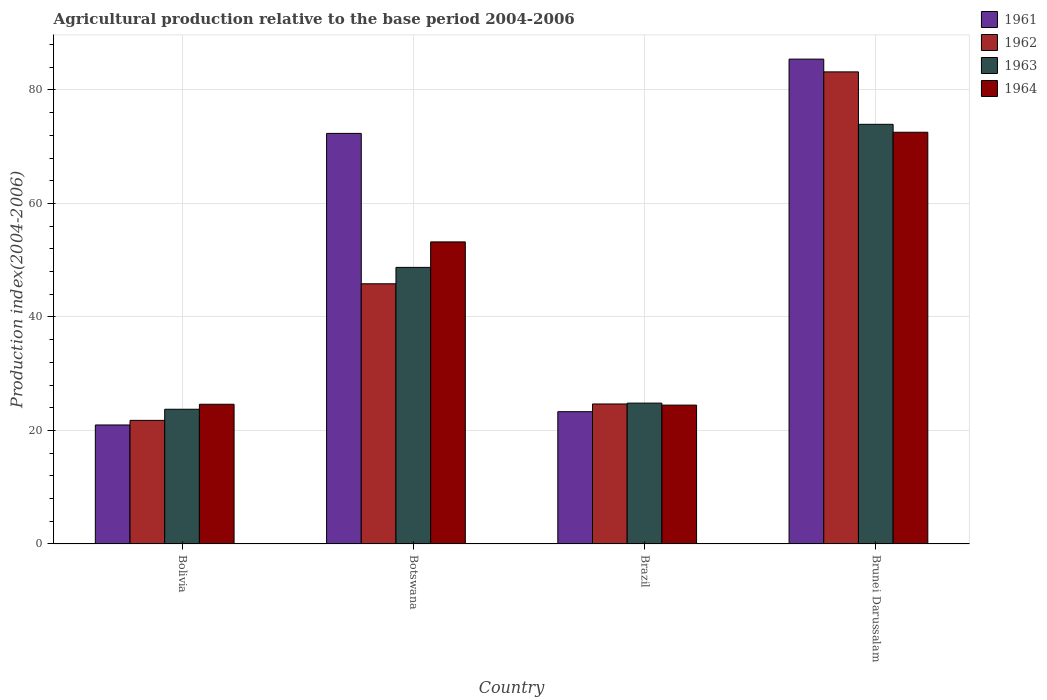How many different coloured bars are there?
Provide a short and direct response. 4. How many groups of bars are there?
Make the answer very short. 4. What is the label of the 4th group of bars from the left?
Your answer should be very brief. Brunei Darussalam. What is the agricultural production index in 1961 in Brunei Darussalam?
Offer a terse response. 85.44. Across all countries, what is the maximum agricultural production index in 1964?
Your answer should be compact. 72.55. Across all countries, what is the minimum agricultural production index in 1962?
Make the answer very short. 21.78. In which country was the agricultural production index in 1962 maximum?
Ensure brevity in your answer.  Brunei Darussalam. What is the total agricultural production index in 1963 in the graph?
Your response must be concise. 171.25. What is the difference between the agricultural production index in 1962 in Bolivia and that in Brazil?
Make the answer very short. -2.89. What is the difference between the agricultural production index in 1964 in Bolivia and the agricultural production index in 1963 in Botswana?
Your response must be concise. -24.12. What is the average agricultural production index in 1964 per country?
Ensure brevity in your answer.  43.72. What is the difference between the agricultural production index of/in 1963 and agricultural production index of/in 1962 in Brazil?
Your answer should be very brief. 0.15. In how many countries, is the agricultural production index in 1963 greater than 52?
Keep it short and to the point. 1. What is the ratio of the agricultural production index in 1962 in Bolivia to that in Botswana?
Ensure brevity in your answer.  0.48. Is the difference between the agricultural production index in 1963 in Botswana and Brunei Darussalam greater than the difference between the agricultural production index in 1962 in Botswana and Brunei Darussalam?
Provide a short and direct response. Yes. What is the difference between the highest and the second highest agricultural production index in 1964?
Offer a terse response. 47.93. What is the difference between the highest and the lowest agricultural production index in 1964?
Your answer should be compact. 48.08. Is the sum of the agricultural production index in 1963 in Bolivia and Brunei Darussalam greater than the maximum agricultural production index in 1964 across all countries?
Your response must be concise. Yes. What does the 4th bar from the left in Botswana represents?
Your answer should be compact. 1964. What does the 1st bar from the right in Brunei Darussalam represents?
Keep it short and to the point. 1964. How many countries are there in the graph?
Provide a short and direct response. 4. Does the graph contain any zero values?
Ensure brevity in your answer.  No. Does the graph contain grids?
Make the answer very short. Yes. How are the legend labels stacked?
Your response must be concise. Vertical. What is the title of the graph?
Offer a very short reply. Agricultural production relative to the base period 2004-2006. Does "1999" appear as one of the legend labels in the graph?
Provide a short and direct response. No. What is the label or title of the Y-axis?
Provide a short and direct response. Production index(2004-2006). What is the Production index(2004-2006) in 1961 in Bolivia?
Give a very brief answer. 20.97. What is the Production index(2004-2006) in 1962 in Bolivia?
Keep it short and to the point. 21.78. What is the Production index(2004-2006) of 1963 in Bolivia?
Offer a very short reply. 23.74. What is the Production index(2004-2006) in 1964 in Bolivia?
Your response must be concise. 24.62. What is the Production index(2004-2006) of 1961 in Botswana?
Offer a terse response. 72.35. What is the Production index(2004-2006) in 1962 in Botswana?
Make the answer very short. 45.85. What is the Production index(2004-2006) of 1963 in Botswana?
Your response must be concise. 48.74. What is the Production index(2004-2006) in 1964 in Botswana?
Provide a succinct answer. 53.23. What is the Production index(2004-2006) in 1961 in Brazil?
Ensure brevity in your answer.  23.31. What is the Production index(2004-2006) in 1962 in Brazil?
Make the answer very short. 24.67. What is the Production index(2004-2006) in 1963 in Brazil?
Your response must be concise. 24.82. What is the Production index(2004-2006) in 1964 in Brazil?
Your answer should be compact. 24.47. What is the Production index(2004-2006) in 1961 in Brunei Darussalam?
Make the answer very short. 85.44. What is the Production index(2004-2006) of 1962 in Brunei Darussalam?
Keep it short and to the point. 83.19. What is the Production index(2004-2006) in 1963 in Brunei Darussalam?
Give a very brief answer. 73.95. What is the Production index(2004-2006) in 1964 in Brunei Darussalam?
Your response must be concise. 72.55. Across all countries, what is the maximum Production index(2004-2006) of 1961?
Ensure brevity in your answer.  85.44. Across all countries, what is the maximum Production index(2004-2006) of 1962?
Your response must be concise. 83.19. Across all countries, what is the maximum Production index(2004-2006) in 1963?
Provide a succinct answer. 73.95. Across all countries, what is the maximum Production index(2004-2006) of 1964?
Keep it short and to the point. 72.55. Across all countries, what is the minimum Production index(2004-2006) of 1961?
Your answer should be very brief. 20.97. Across all countries, what is the minimum Production index(2004-2006) in 1962?
Make the answer very short. 21.78. Across all countries, what is the minimum Production index(2004-2006) in 1963?
Ensure brevity in your answer.  23.74. Across all countries, what is the minimum Production index(2004-2006) in 1964?
Your answer should be compact. 24.47. What is the total Production index(2004-2006) of 1961 in the graph?
Ensure brevity in your answer.  202.07. What is the total Production index(2004-2006) of 1962 in the graph?
Make the answer very short. 175.49. What is the total Production index(2004-2006) of 1963 in the graph?
Ensure brevity in your answer.  171.25. What is the total Production index(2004-2006) in 1964 in the graph?
Your response must be concise. 174.87. What is the difference between the Production index(2004-2006) of 1961 in Bolivia and that in Botswana?
Your response must be concise. -51.38. What is the difference between the Production index(2004-2006) of 1962 in Bolivia and that in Botswana?
Offer a very short reply. -24.07. What is the difference between the Production index(2004-2006) in 1963 in Bolivia and that in Botswana?
Provide a succinct answer. -25. What is the difference between the Production index(2004-2006) of 1964 in Bolivia and that in Botswana?
Ensure brevity in your answer.  -28.61. What is the difference between the Production index(2004-2006) in 1961 in Bolivia and that in Brazil?
Your answer should be compact. -2.34. What is the difference between the Production index(2004-2006) of 1962 in Bolivia and that in Brazil?
Make the answer very short. -2.89. What is the difference between the Production index(2004-2006) in 1963 in Bolivia and that in Brazil?
Keep it short and to the point. -1.08. What is the difference between the Production index(2004-2006) of 1964 in Bolivia and that in Brazil?
Make the answer very short. 0.15. What is the difference between the Production index(2004-2006) of 1961 in Bolivia and that in Brunei Darussalam?
Keep it short and to the point. -64.47. What is the difference between the Production index(2004-2006) of 1962 in Bolivia and that in Brunei Darussalam?
Keep it short and to the point. -61.41. What is the difference between the Production index(2004-2006) in 1963 in Bolivia and that in Brunei Darussalam?
Make the answer very short. -50.21. What is the difference between the Production index(2004-2006) in 1964 in Bolivia and that in Brunei Darussalam?
Make the answer very short. -47.93. What is the difference between the Production index(2004-2006) of 1961 in Botswana and that in Brazil?
Provide a succinct answer. 49.04. What is the difference between the Production index(2004-2006) in 1962 in Botswana and that in Brazil?
Make the answer very short. 21.18. What is the difference between the Production index(2004-2006) in 1963 in Botswana and that in Brazil?
Offer a very short reply. 23.92. What is the difference between the Production index(2004-2006) of 1964 in Botswana and that in Brazil?
Your answer should be compact. 28.76. What is the difference between the Production index(2004-2006) of 1961 in Botswana and that in Brunei Darussalam?
Offer a terse response. -13.09. What is the difference between the Production index(2004-2006) in 1962 in Botswana and that in Brunei Darussalam?
Your answer should be very brief. -37.34. What is the difference between the Production index(2004-2006) in 1963 in Botswana and that in Brunei Darussalam?
Your answer should be very brief. -25.21. What is the difference between the Production index(2004-2006) in 1964 in Botswana and that in Brunei Darussalam?
Provide a short and direct response. -19.32. What is the difference between the Production index(2004-2006) of 1961 in Brazil and that in Brunei Darussalam?
Give a very brief answer. -62.13. What is the difference between the Production index(2004-2006) of 1962 in Brazil and that in Brunei Darussalam?
Offer a terse response. -58.52. What is the difference between the Production index(2004-2006) of 1963 in Brazil and that in Brunei Darussalam?
Keep it short and to the point. -49.13. What is the difference between the Production index(2004-2006) in 1964 in Brazil and that in Brunei Darussalam?
Your response must be concise. -48.08. What is the difference between the Production index(2004-2006) of 1961 in Bolivia and the Production index(2004-2006) of 1962 in Botswana?
Your answer should be compact. -24.88. What is the difference between the Production index(2004-2006) of 1961 in Bolivia and the Production index(2004-2006) of 1963 in Botswana?
Give a very brief answer. -27.77. What is the difference between the Production index(2004-2006) in 1961 in Bolivia and the Production index(2004-2006) in 1964 in Botswana?
Your answer should be compact. -32.26. What is the difference between the Production index(2004-2006) of 1962 in Bolivia and the Production index(2004-2006) of 1963 in Botswana?
Provide a short and direct response. -26.96. What is the difference between the Production index(2004-2006) of 1962 in Bolivia and the Production index(2004-2006) of 1964 in Botswana?
Give a very brief answer. -31.45. What is the difference between the Production index(2004-2006) of 1963 in Bolivia and the Production index(2004-2006) of 1964 in Botswana?
Provide a short and direct response. -29.49. What is the difference between the Production index(2004-2006) of 1961 in Bolivia and the Production index(2004-2006) of 1962 in Brazil?
Offer a very short reply. -3.7. What is the difference between the Production index(2004-2006) in 1961 in Bolivia and the Production index(2004-2006) in 1963 in Brazil?
Provide a succinct answer. -3.85. What is the difference between the Production index(2004-2006) of 1961 in Bolivia and the Production index(2004-2006) of 1964 in Brazil?
Your answer should be compact. -3.5. What is the difference between the Production index(2004-2006) in 1962 in Bolivia and the Production index(2004-2006) in 1963 in Brazil?
Keep it short and to the point. -3.04. What is the difference between the Production index(2004-2006) of 1962 in Bolivia and the Production index(2004-2006) of 1964 in Brazil?
Provide a short and direct response. -2.69. What is the difference between the Production index(2004-2006) of 1963 in Bolivia and the Production index(2004-2006) of 1964 in Brazil?
Offer a terse response. -0.73. What is the difference between the Production index(2004-2006) of 1961 in Bolivia and the Production index(2004-2006) of 1962 in Brunei Darussalam?
Offer a terse response. -62.22. What is the difference between the Production index(2004-2006) of 1961 in Bolivia and the Production index(2004-2006) of 1963 in Brunei Darussalam?
Offer a terse response. -52.98. What is the difference between the Production index(2004-2006) in 1961 in Bolivia and the Production index(2004-2006) in 1964 in Brunei Darussalam?
Your response must be concise. -51.58. What is the difference between the Production index(2004-2006) of 1962 in Bolivia and the Production index(2004-2006) of 1963 in Brunei Darussalam?
Your response must be concise. -52.17. What is the difference between the Production index(2004-2006) of 1962 in Bolivia and the Production index(2004-2006) of 1964 in Brunei Darussalam?
Provide a succinct answer. -50.77. What is the difference between the Production index(2004-2006) of 1963 in Bolivia and the Production index(2004-2006) of 1964 in Brunei Darussalam?
Give a very brief answer. -48.81. What is the difference between the Production index(2004-2006) in 1961 in Botswana and the Production index(2004-2006) in 1962 in Brazil?
Offer a terse response. 47.68. What is the difference between the Production index(2004-2006) in 1961 in Botswana and the Production index(2004-2006) in 1963 in Brazil?
Offer a very short reply. 47.53. What is the difference between the Production index(2004-2006) of 1961 in Botswana and the Production index(2004-2006) of 1964 in Brazil?
Your response must be concise. 47.88. What is the difference between the Production index(2004-2006) in 1962 in Botswana and the Production index(2004-2006) in 1963 in Brazil?
Offer a terse response. 21.03. What is the difference between the Production index(2004-2006) of 1962 in Botswana and the Production index(2004-2006) of 1964 in Brazil?
Make the answer very short. 21.38. What is the difference between the Production index(2004-2006) of 1963 in Botswana and the Production index(2004-2006) of 1964 in Brazil?
Your answer should be very brief. 24.27. What is the difference between the Production index(2004-2006) in 1961 in Botswana and the Production index(2004-2006) in 1962 in Brunei Darussalam?
Keep it short and to the point. -10.84. What is the difference between the Production index(2004-2006) of 1961 in Botswana and the Production index(2004-2006) of 1963 in Brunei Darussalam?
Keep it short and to the point. -1.6. What is the difference between the Production index(2004-2006) in 1961 in Botswana and the Production index(2004-2006) in 1964 in Brunei Darussalam?
Your response must be concise. -0.2. What is the difference between the Production index(2004-2006) of 1962 in Botswana and the Production index(2004-2006) of 1963 in Brunei Darussalam?
Offer a very short reply. -28.1. What is the difference between the Production index(2004-2006) of 1962 in Botswana and the Production index(2004-2006) of 1964 in Brunei Darussalam?
Your answer should be very brief. -26.7. What is the difference between the Production index(2004-2006) of 1963 in Botswana and the Production index(2004-2006) of 1964 in Brunei Darussalam?
Give a very brief answer. -23.81. What is the difference between the Production index(2004-2006) of 1961 in Brazil and the Production index(2004-2006) of 1962 in Brunei Darussalam?
Your answer should be very brief. -59.88. What is the difference between the Production index(2004-2006) of 1961 in Brazil and the Production index(2004-2006) of 1963 in Brunei Darussalam?
Offer a very short reply. -50.64. What is the difference between the Production index(2004-2006) of 1961 in Brazil and the Production index(2004-2006) of 1964 in Brunei Darussalam?
Give a very brief answer. -49.24. What is the difference between the Production index(2004-2006) in 1962 in Brazil and the Production index(2004-2006) in 1963 in Brunei Darussalam?
Your response must be concise. -49.28. What is the difference between the Production index(2004-2006) of 1962 in Brazil and the Production index(2004-2006) of 1964 in Brunei Darussalam?
Your answer should be very brief. -47.88. What is the difference between the Production index(2004-2006) in 1963 in Brazil and the Production index(2004-2006) in 1964 in Brunei Darussalam?
Your answer should be compact. -47.73. What is the average Production index(2004-2006) of 1961 per country?
Your answer should be compact. 50.52. What is the average Production index(2004-2006) in 1962 per country?
Provide a short and direct response. 43.87. What is the average Production index(2004-2006) in 1963 per country?
Offer a terse response. 42.81. What is the average Production index(2004-2006) in 1964 per country?
Make the answer very short. 43.72. What is the difference between the Production index(2004-2006) of 1961 and Production index(2004-2006) of 1962 in Bolivia?
Your answer should be very brief. -0.81. What is the difference between the Production index(2004-2006) in 1961 and Production index(2004-2006) in 1963 in Bolivia?
Provide a succinct answer. -2.77. What is the difference between the Production index(2004-2006) in 1961 and Production index(2004-2006) in 1964 in Bolivia?
Make the answer very short. -3.65. What is the difference between the Production index(2004-2006) of 1962 and Production index(2004-2006) of 1963 in Bolivia?
Your answer should be very brief. -1.96. What is the difference between the Production index(2004-2006) in 1962 and Production index(2004-2006) in 1964 in Bolivia?
Provide a short and direct response. -2.84. What is the difference between the Production index(2004-2006) of 1963 and Production index(2004-2006) of 1964 in Bolivia?
Your answer should be compact. -0.88. What is the difference between the Production index(2004-2006) in 1961 and Production index(2004-2006) in 1963 in Botswana?
Give a very brief answer. 23.61. What is the difference between the Production index(2004-2006) of 1961 and Production index(2004-2006) of 1964 in Botswana?
Your response must be concise. 19.12. What is the difference between the Production index(2004-2006) of 1962 and Production index(2004-2006) of 1963 in Botswana?
Keep it short and to the point. -2.89. What is the difference between the Production index(2004-2006) of 1962 and Production index(2004-2006) of 1964 in Botswana?
Offer a terse response. -7.38. What is the difference between the Production index(2004-2006) of 1963 and Production index(2004-2006) of 1964 in Botswana?
Give a very brief answer. -4.49. What is the difference between the Production index(2004-2006) in 1961 and Production index(2004-2006) in 1962 in Brazil?
Offer a very short reply. -1.36. What is the difference between the Production index(2004-2006) of 1961 and Production index(2004-2006) of 1963 in Brazil?
Your answer should be very brief. -1.51. What is the difference between the Production index(2004-2006) of 1961 and Production index(2004-2006) of 1964 in Brazil?
Your response must be concise. -1.16. What is the difference between the Production index(2004-2006) in 1961 and Production index(2004-2006) in 1962 in Brunei Darussalam?
Your answer should be very brief. 2.25. What is the difference between the Production index(2004-2006) of 1961 and Production index(2004-2006) of 1963 in Brunei Darussalam?
Offer a terse response. 11.49. What is the difference between the Production index(2004-2006) in 1961 and Production index(2004-2006) in 1964 in Brunei Darussalam?
Provide a succinct answer. 12.89. What is the difference between the Production index(2004-2006) in 1962 and Production index(2004-2006) in 1963 in Brunei Darussalam?
Provide a succinct answer. 9.24. What is the difference between the Production index(2004-2006) of 1962 and Production index(2004-2006) of 1964 in Brunei Darussalam?
Give a very brief answer. 10.64. What is the difference between the Production index(2004-2006) in 1963 and Production index(2004-2006) in 1964 in Brunei Darussalam?
Your response must be concise. 1.4. What is the ratio of the Production index(2004-2006) in 1961 in Bolivia to that in Botswana?
Your answer should be compact. 0.29. What is the ratio of the Production index(2004-2006) in 1962 in Bolivia to that in Botswana?
Your answer should be very brief. 0.47. What is the ratio of the Production index(2004-2006) of 1963 in Bolivia to that in Botswana?
Your answer should be very brief. 0.49. What is the ratio of the Production index(2004-2006) of 1964 in Bolivia to that in Botswana?
Make the answer very short. 0.46. What is the ratio of the Production index(2004-2006) in 1961 in Bolivia to that in Brazil?
Give a very brief answer. 0.9. What is the ratio of the Production index(2004-2006) in 1962 in Bolivia to that in Brazil?
Your answer should be very brief. 0.88. What is the ratio of the Production index(2004-2006) in 1963 in Bolivia to that in Brazil?
Offer a terse response. 0.96. What is the ratio of the Production index(2004-2006) of 1961 in Bolivia to that in Brunei Darussalam?
Ensure brevity in your answer.  0.25. What is the ratio of the Production index(2004-2006) in 1962 in Bolivia to that in Brunei Darussalam?
Ensure brevity in your answer.  0.26. What is the ratio of the Production index(2004-2006) in 1963 in Bolivia to that in Brunei Darussalam?
Provide a short and direct response. 0.32. What is the ratio of the Production index(2004-2006) in 1964 in Bolivia to that in Brunei Darussalam?
Keep it short and to the point. 0.34. What is the ratio of the Production index(2004-2006) in 1961 in Botswana to that in Brazil?
Ensure brevity in your answer.  3.1. What is the ratio of the Production index(2004-2006) in 1962 in Botswana to that in Brazil?
Make the answer very short. 1.86. What is the ratio of the Production index(2004-2006) of 1963 in Botswana to that in Brazil?
Ensure brevity in your answer.  1.96. What is the ratio of the Production index(2004-2006) in 1964 in Botswana to that in Brazil?
Offer a terse response. 2.18. What is the ratio of the Production index(2004-2006) in 1961 in Botswana to that in Brunei Darussalam?
Ensure brevity in your answer.  0.85. What is the ratio of the Production index(2004-2006) in 1962 in Botswana to that in Brunei Darussalam?
Offer a terse response. 0.55. What is the ratio of the Production index(2004-2006) in 1963 in Botswana to that in Brunei Darussalam?
Offer a terse response. 0.66. What is the ratio of the Production index(2004-2006) of 1964 in Botswana to that in Brunei Darussalam?
Your response must be concise. 0.73. What is the ratio of the Production index(2004-2006) of 1961 in Brazil to that in Brunei Darussalam?
Your answer should be compact. 0.27. What is the ratio of the Production index(2004-2006) of 1962 in Brazil to that in Brunei Darussalam?
Provide a succinct answer. 0.3. What is the ratio of the Production index(2004-2006) in 1963 in Brazil to that in Brunei Darussalam?
Make the answer very short. 0.34. What is the ratio of the Production index(2004-2006) of 1964 in Brazil to that in Brunei Darussalam?
Offer a very short reply. 0.34. What is the difference between the highest and the second highest Production index(2004-2006) in 1961?
Your answer should be compact. 13.09. What is the difference between the highest and the second highest Production index(2004-2006) of 1962?
Provide a succinct answer. 37.34. What is the difference between the highest and the second highest Production index(2004-2006) in 1963?
Offer a terse response. 25.21. What is the difference between the highest and the second highest Production index(2004-2006) of 1964?
Keep it short and to the point. 19.32. What is the difference between the highest and the lowest Production index(2004-2006) in 1961?
Give a very brief answer. 64.47. What is the difference between the highest and the lowest Production index(2004-2006) of 1962?
Provide a succinct answer. 61.41. What is the difference between the highest and the lowest Production index(2004-2006) in 1963?
Your response must be concise. 50.21. What is the difference between the highest and the lowest Production index(2004-2006) in 1964?
Offer a terse response. 48.08. 